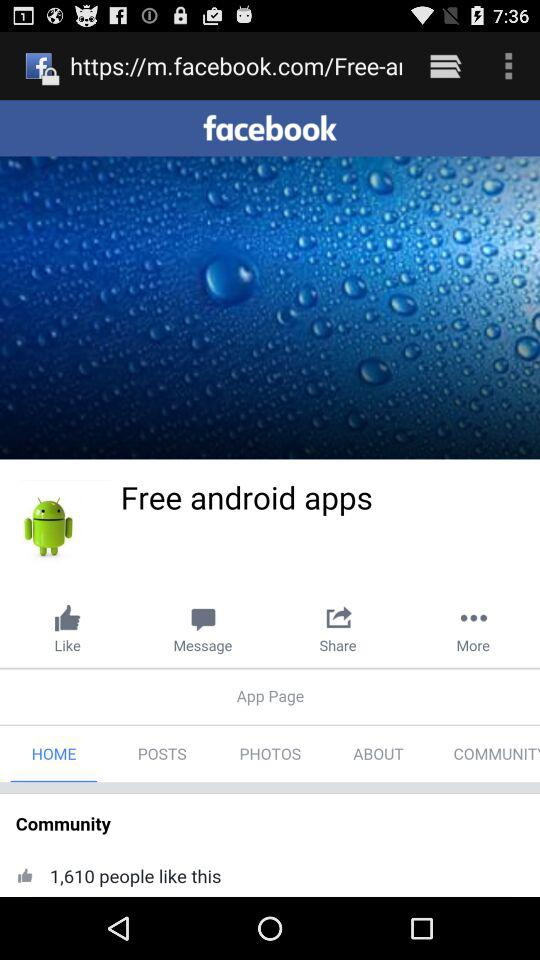How many people liked the app page? The app page is liked by 1,610. 